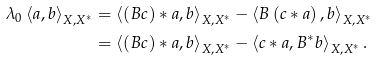<formula> <loc_0><loc_0><loc_500><loc_500>\lambda _ { 0 } \left \langle a , b \right \rangle _ { X , X ^ { \ast } } & = \left \langle ( B c ) * a , b \right \rangle _ { X , X ^ { \ast } } - \left \langle B \left ( c * a \right ) , b \right \rangle _ { X , X ^ { \ast } } \\ & = \left \langle ( B c ) * a , b \right \rangle _ { X , X ^ { \ast } } - \left \langle c * a , B ^ { \ast } b \right \rangle _ { X , X ^ { \ast } } .</formula> 